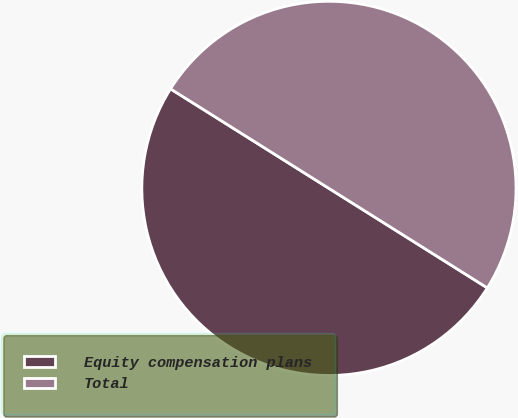Convert chart to OTSL. <chart><loc_0><loc_0><loc_500><loc_500><pie_chart><fcel>Equity compensation plans<fcel>Total<nl><fcel>50.0%<fcel>50.0%<nl></chart> 